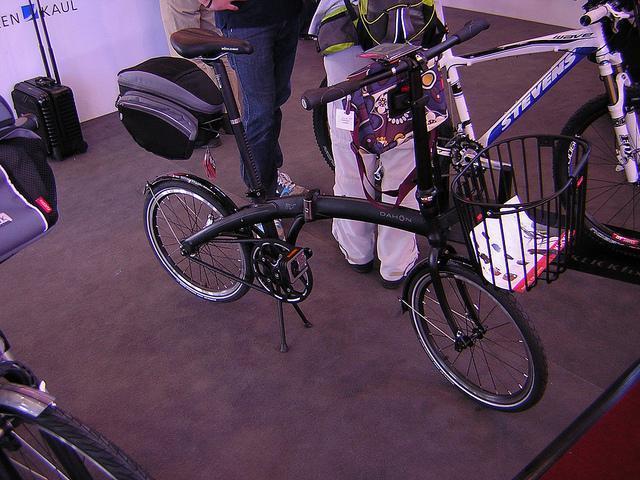How many rackets are in his backpack?
Give a very brief answer. 0. How many handbags can be seen?
Give a very brief answer. 1. How many bicycles are visible?
Give a very brief answer. 3. How many backpacks are there?
Give a very brief answer. 2. How many people are there?
Give a very brief answer. 3. 